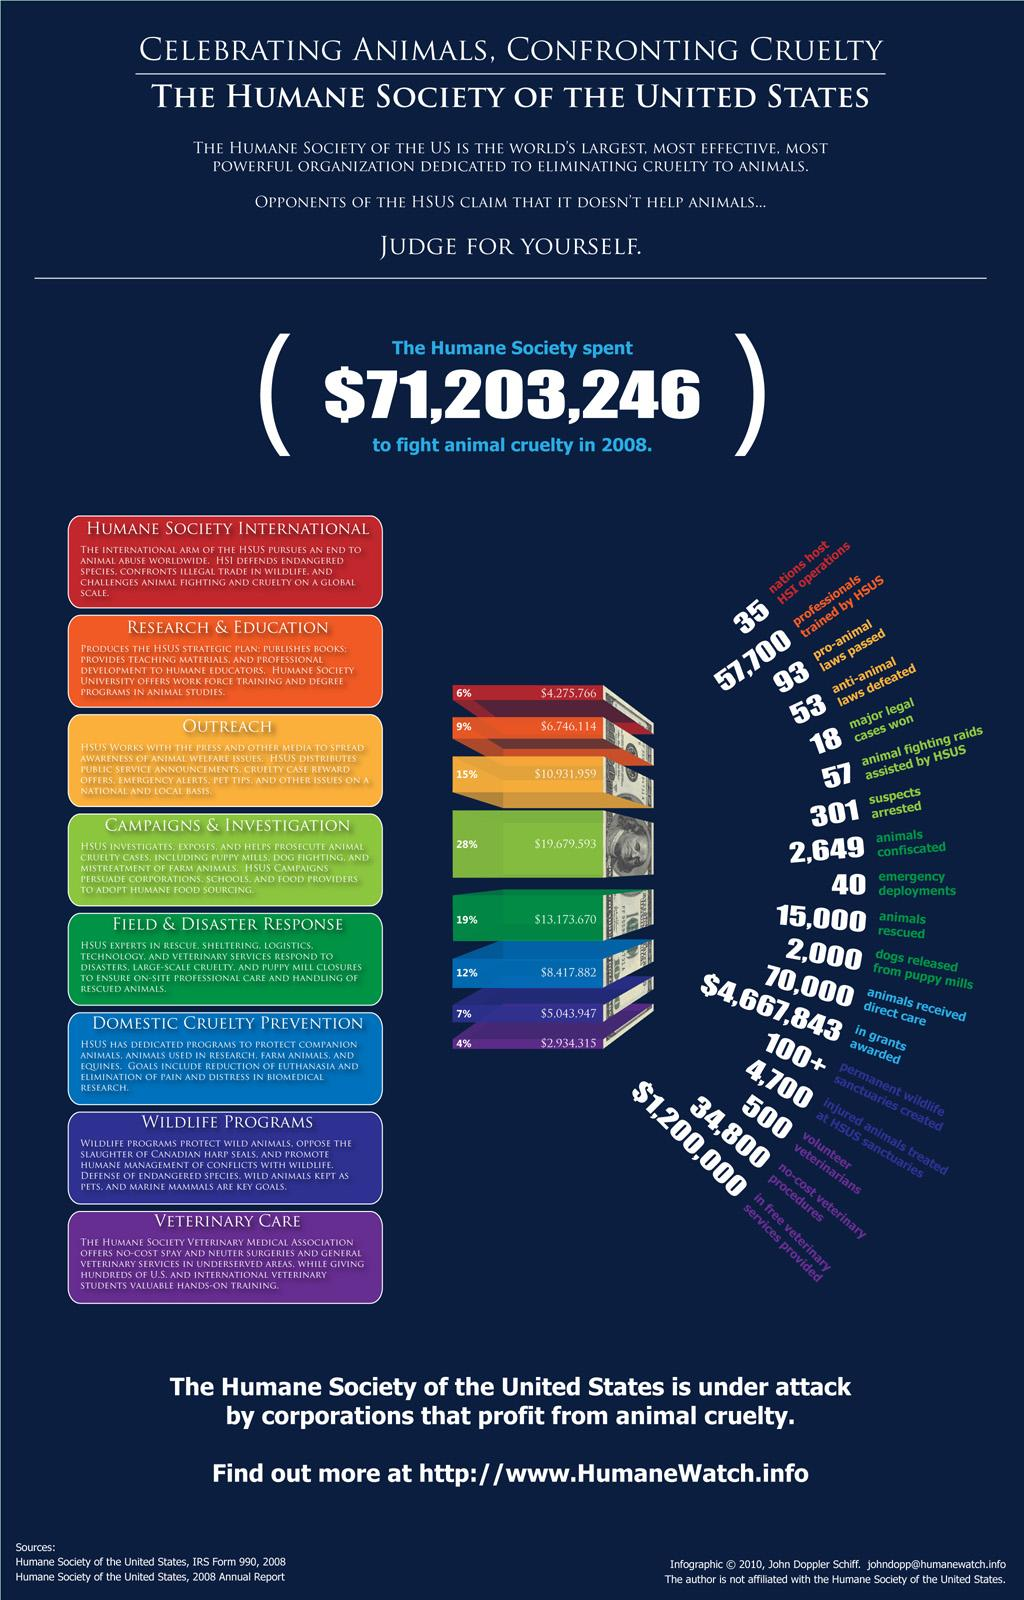Identify some key points in this picture. Out of the total amount of money spent, 28% has been allocated towards campaigns and investigations. 